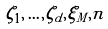Convert formula to latex. <formula><loc_0><loc_0><loc_500><loc_500>\label l { b a s i s 1 } \zeta _ { 1 } , \dots , \zeta _ { d } , \xi _ { M } , n</formula> 